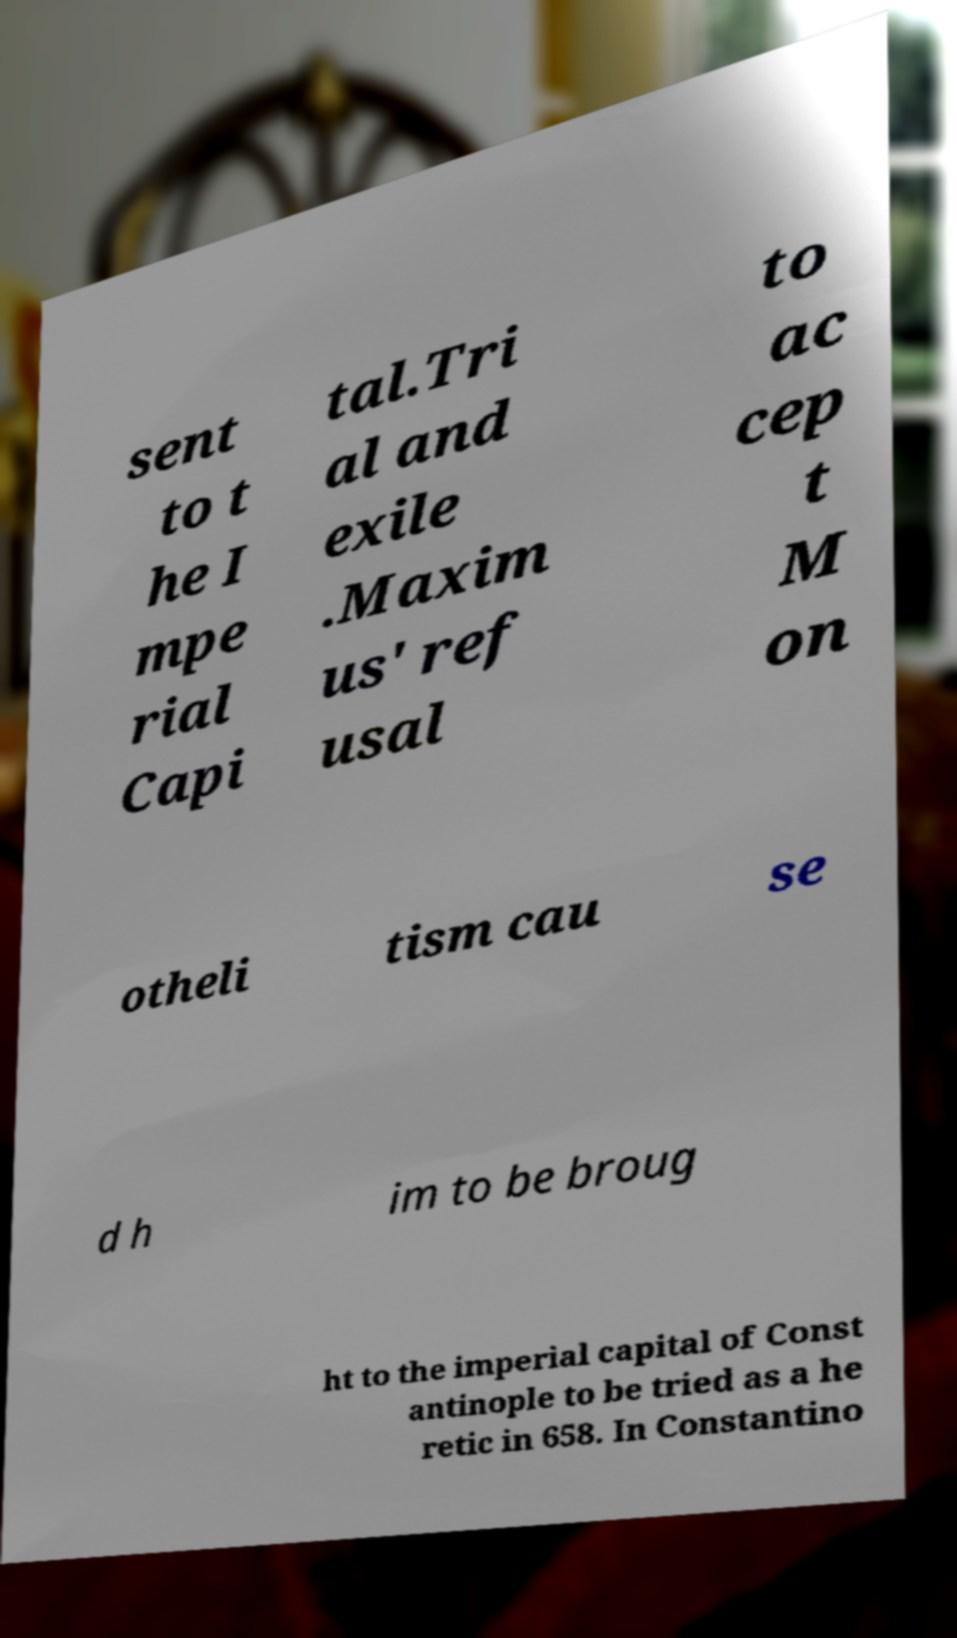I need the written content from this picture converted into text. Can you do that? sent to t he I mpe rial Capi tal.Tri al and exile .Maxim us' ref usal to ac cep t M on otheli tism cau se d h im to be broug ht to the imperial capital of Const antinople to be tried as a he retic in 658. In Constantino 